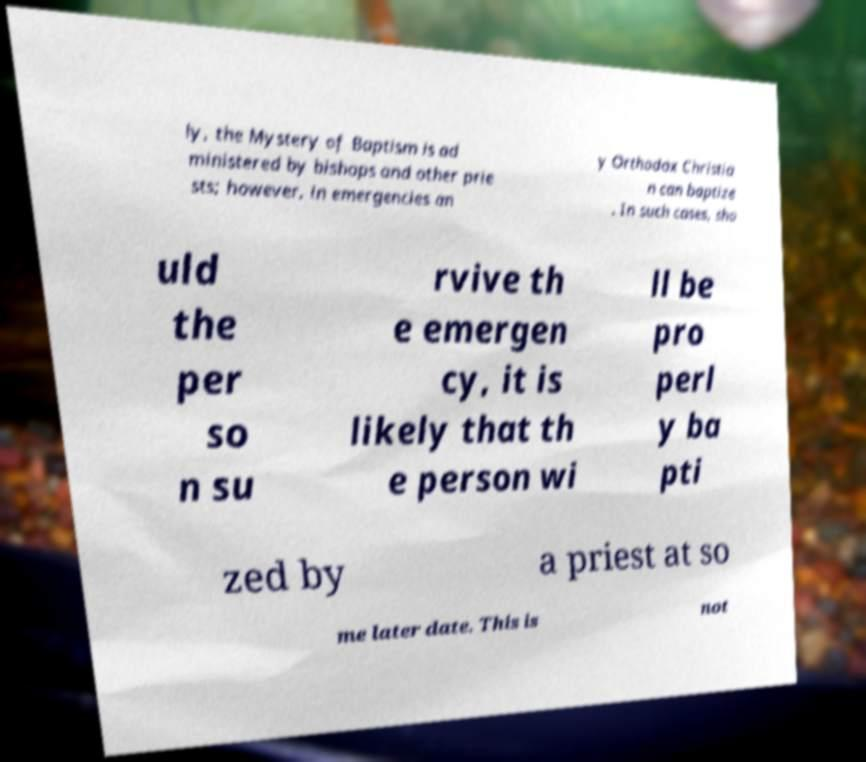Could you extract and type out the text from this image? ly, the Mystery of Baptism is ad ministered by bishops and other prie sts; however, in emergencies an y Orthodox Christia n can baptize . In such cases, sho uld the per so n su rvive th e emergen cy, it is likely that th e person wi ll be pro perl y ba pti zed by a priest at so me later date. This is not 